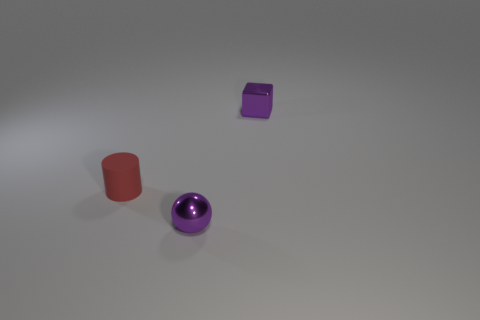Add 2 matte cylinders. How many objects exist? 5 Subtract all cylinders. How many objects are left? 2 Add 3 small matte things. How many small matte things are left? 4 Add 3 purple objects. How many purple objects exist? 5 Subtract 0 brown spheres. How many objects are left? 3 Subtract all spheres. Subtract all tiny blue cylinders. How many objects are left? 2 